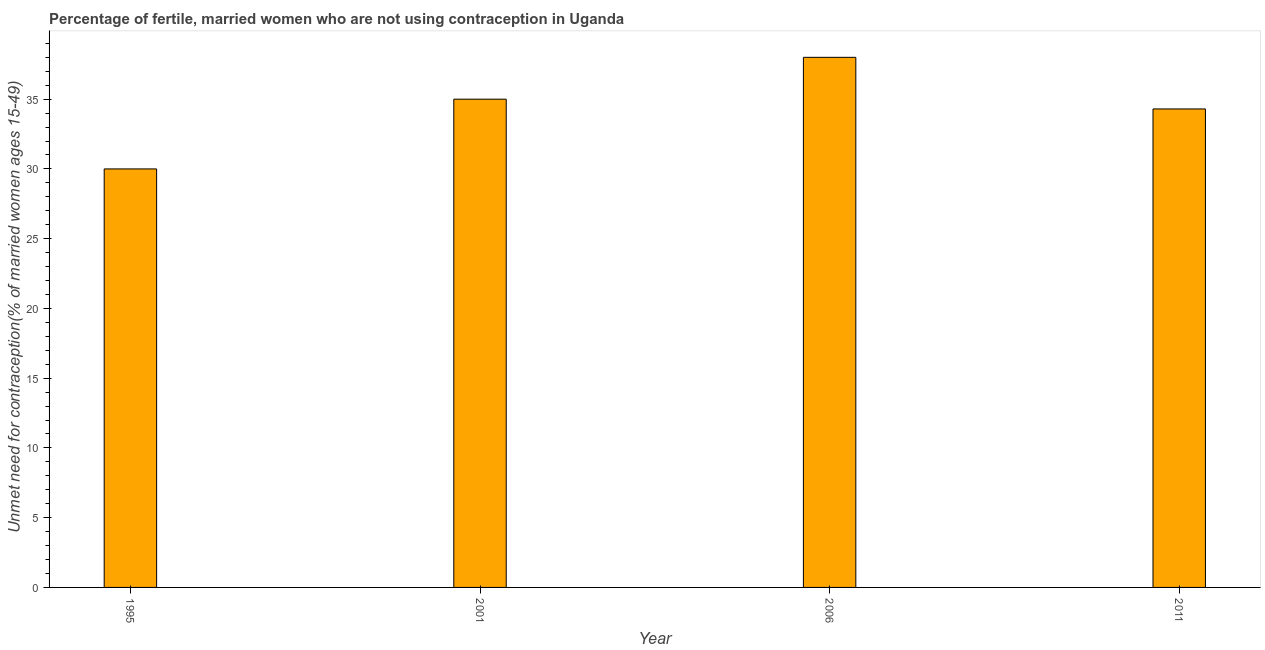Does the graph contain any zero values?
Give a very brief answer. No. Does the graph contain grids?
Your answer should be very brief. No. What is the title of the graph?
Offer a very short reply. Percentage of fertile, married women who are not using contraception in Uganda. What is the label or title of the X-axis?
Your answer should be very brief. Year. What is the label or title of the Y-axis?
Provide a short and direct response.  Unmet need for contraception(% of married women ages 15-49). Across all years, what is the minimum number of married women who are not using contraception?
Give a very brief answer. 30. In which year was the number of married women who are not using contraception maximum?
Your answer should be compact. 2006. What is the sum of the number of married women who are not using contraception?
Your response must be concise. 137.3. What is the difference between the number of married women who are not using contraception in 1995 and 2001?
Offer a terse response. -5. What is the average number of married women who are not using contraception per year?
Give a very brief answer. 34.33. What is the median number of married women who are not using contraception?
Make the answer very short. 34.65. In how many years, is the number of married women who are not using contraception greater than 1 %?
Provide a short and direct response. 4. Do a majority of the years between 1995 and 2011 (inclusive) have number of married women who are not using contraception greater than 7 %?
Your answer should be compact. Yes. What is the ratio of the number of married women who are not using contraception in 1995 to that in 2006?
Provide a short and direct response. 0.79. In how many years, is the number of married women who are not using contraception greater than the average number of married women who are not using contraception taken over all years?
Your answer should be compact. 2. How many bars are there?
Offer a terse response. 4. Are all the bars in the graph horizontal?
Provide a succinct answer. No. How many years are there in the graph?
Your response must be concise. 4. What is the  Unmet need for contraception(% of married women ages 15-49) of 2006?
Your response must be concise. 38. What is the  Unmet need for contraception(% of married women ages 15-49) of 2011?
Your answer should be compact. 34.3. What is the difference between the  Unmet need for contraception(% of married women ages 15-49) in 1995 and 2001?
Ensure brevity in your answer.  -5. What is the difference between the  Unmet need for contraception(% of married women ages 15-49) in 1995 and 2006?
Your answer should be compact. -8. What is the difference between the  Unmet need for contraception(% of married women ages 15-49) in 1995 and 2011?
Make the answer very short. -4.3. What is the difference between the  Unmet need for contraception(% of married women ages 15-49) in 2001 and 2006?
Your answer should be compact. -3. What is the difference between the  Unmet need for contraception(% of married women ages 15-49) in 2001 and 2011?
Ensure brevity in your answer.  0.7. What is the difference between the  Unmet need for contraception(% of married women ages 15-49) in 2006 and 2011?
Make the answer very short. 3.7. What is the ratio of the  Unmet need for contraception(% of married women ages 15-49) in 1995 to that in 2001?
Make the answer very short. 0.86. What is the ratio of the  Unmet need for contraception(% of married women ages 15-49) in 1995 to that in 2006?
Your response must be concise. 0.79. What is the ratio of the  Unmet need for contraception(% of married women ages 15-49) in 1995 to that in 2011?
Provide a succinct answer. 0.88. What is the ratio of the  Unmet need for contraception(% of married women ages 15-49) in 2001 to that in 2006?
Offer a very short reply. 0.92. What is the ratio of the  Unmet need for contraception(% of married women ages 15-49) in 2006 to that in 2011?
Your response must be concise. 1.11. 